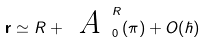Convert formula to latex. <formula><loc_0><loc_0><loc_500><loc_500>\mathbf { r } \simeq R + \emph { A } _ { 0 } ^ { R } ( \pi ) + O ( \hbar { ) }</formula> 